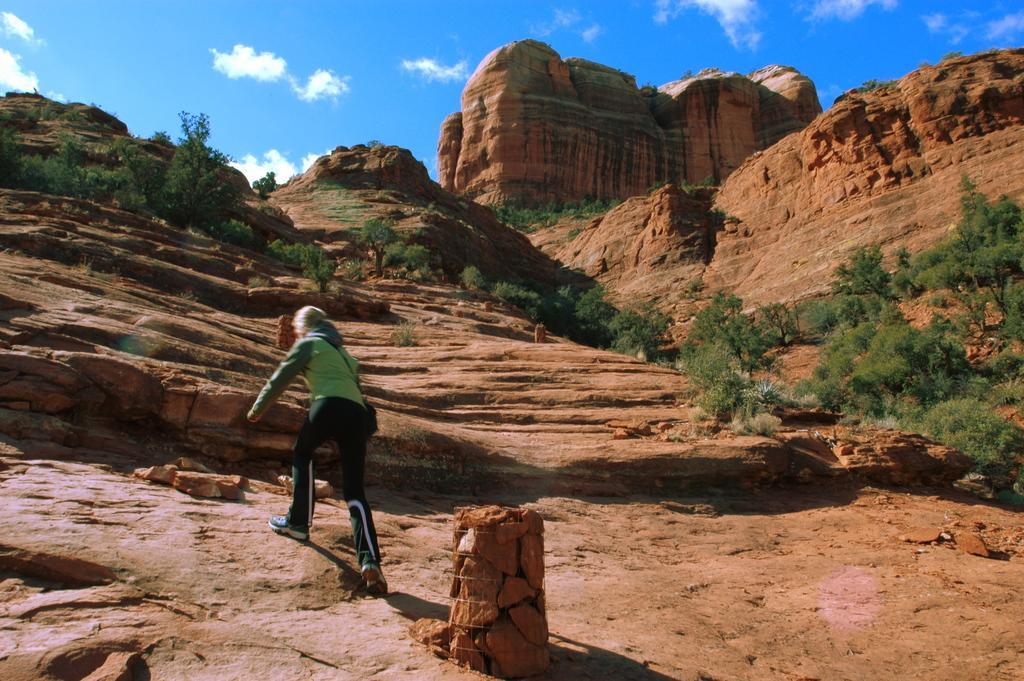Can you describe this image briefly? In the center of the image we can see a lady is climbing the hill. In the background of the image we can see the hills, trees. At the top of the image we can see the clouds in the sky. 